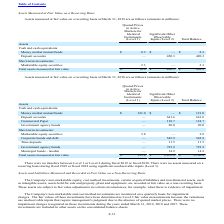According to Microchip Technology's financial document, What was the total balance for Money market mutual funds? According to the financial document, 121.0 (in millions). The relevant text states: "Money market mutual funds $ 121.0 $ — $ 121.0..." Also, What was the total balance amount of deposit accounts? According to the financial document, 641.6 (in millions). The relevant text states: "Deposit accounts — 641.6 641.6..." Also, What was the total balance time deposits? According to the financial document, 11.5 (in millions). The relevant text states: "Time deposits — 11.5 11.5..." Also, can you calculate: What was the difference in the total balance between Money market mutual funds and commercial paper? Based on the calculation: 121.0-118.7, the result is 2.3 (in millions). This is based on the information: "Commercial Paper — 118.7 118.7 Money market mutual funds $ 121.0 $ — $ 121.0..." The key data points involved are: 118.7, 121.0. Also, How many Short-term investments had a total balance that exceeded $500 million? Counting the relevant items in the document: Corporate bonds and debt, Government agency bonds, I find 2 instances. The key data points involved are: Corporate bonds and debt, Government agency bonds. Also, can you calculate: What was the total balance amount of short-term Government agency bonds as a percentage of the total balance of assets? Based on the calculation: 723.2/2,196.6, the result is 32.92 (percentage). This is based on the information: "assets measured at fair value $ 123.8 $ 2,072.8 $ 2,196.6 Government agency bonds — 723.2 723.2..." The key data points involved are: 2,196.6, 723.2. 